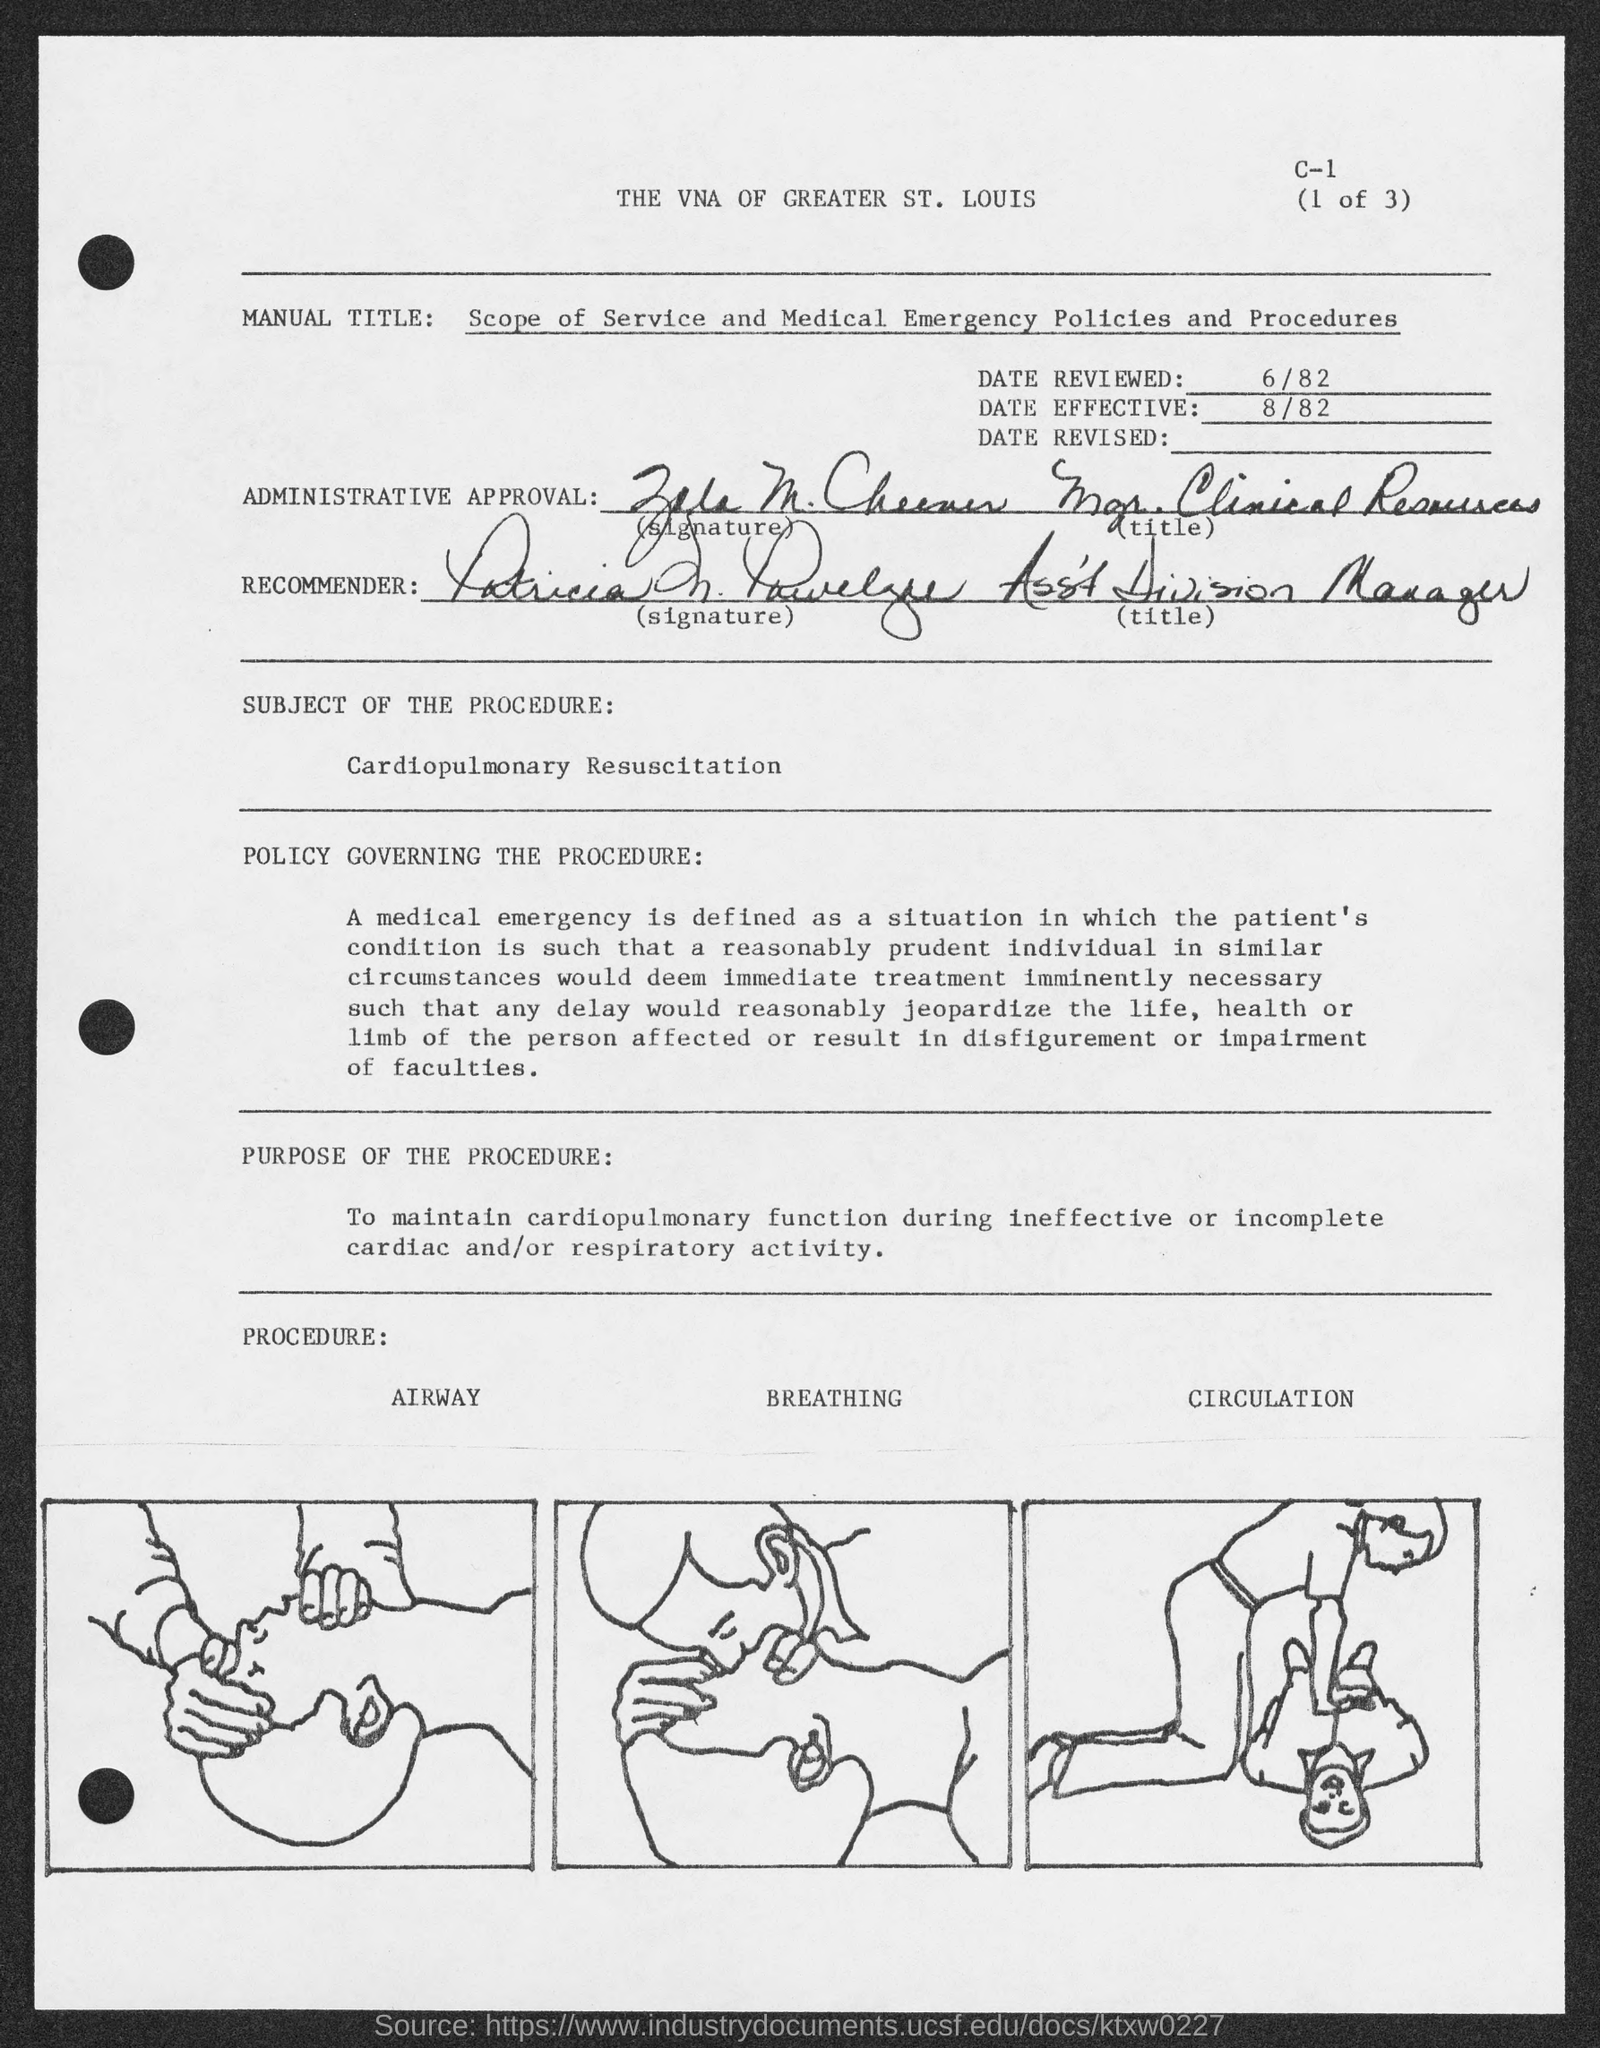Highlight a few significant elements in this photo. The title of the document is "What is the Title of the document? The VNA of greater St. Louis.. The question "What is the date effective?" is asking for information about a specific date that is being referred to. The date in question is "8/82," which is August 8th, 1982. The date reviewed is 6/82. 